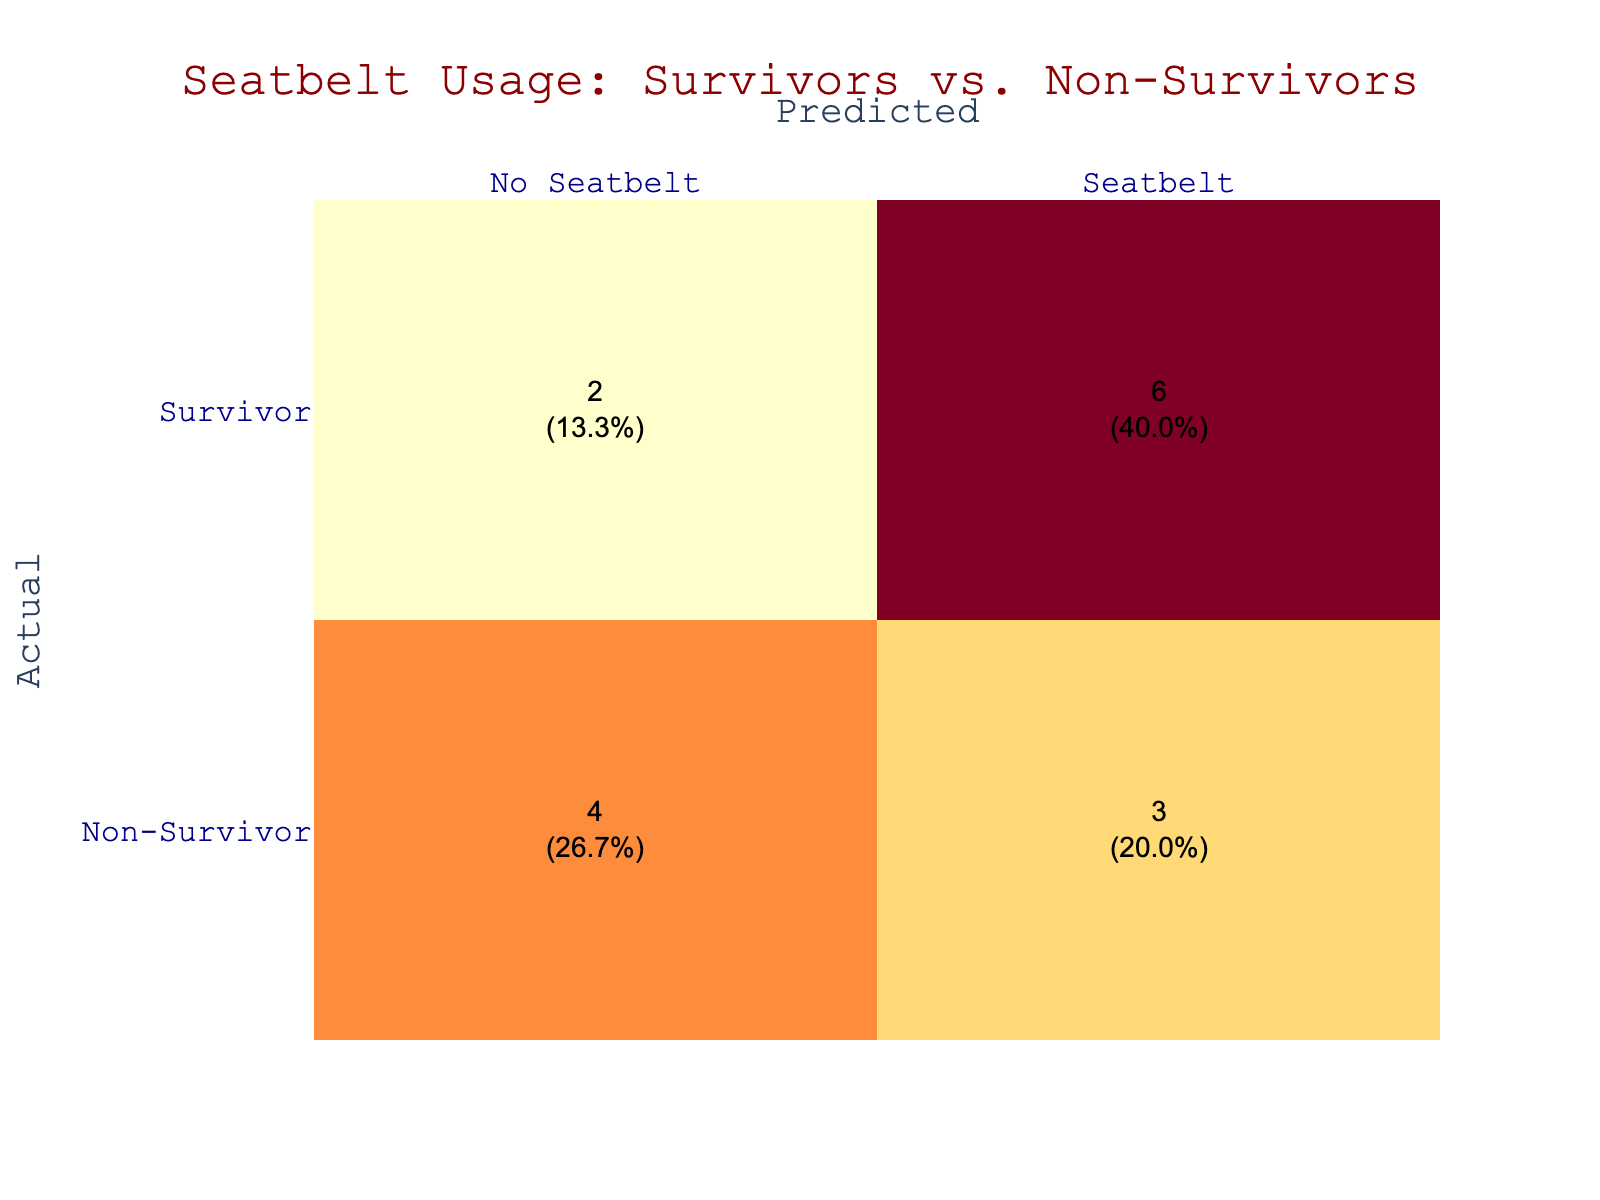What is the total number of survivors who used seatbelts? Referring to the table, I can see that there are four instances where survivors are predicted to have used seatbelts (Seatbelt under the Survivor category).
Answer: 4 How many non-survivors were observed to not use seatbelts? By checking the row for non-survivors and looking at the 'No Seatbelt' column, I find that there are four instances where non-survivors did not use seatbelts.
Answer: 4 Is it true that more survivors used seatbelts than non-survivors? To answer this, I can compare the totals for seatbelt usage: survivors who used seatbelts (4) and non-survivors who used seatbelts (3). Since 4 is greater than 3, the statement is true.
Answer: Yes What percentage of the total accidents involved survivors using seatbelts? First, I need to find the total number of cases, which is 15 (adding all entries). Next, I see there are 4 survivors using seatbelts. To get the percentage: (4/15)*100 = 26.7%.
Answer: 26.7% What is the difference between the number of non-survivors who used seatbelts and survivors who did not? Counting the non-survivors who used seatbelts gives me 3, and the survivors who did not use seatbelts is also 3. The difference is calculated as 3 - 3 = 0.
Answer: 0 How many total instances involved predictions of survivors? Looking at the table, there are 8 instances where the actual outcome is labeled as Survivor.
Answer: 8 What is the ratio of non-survivors using seatbelts to total non-survivors? From the table, I know there are 3 non-survivors using seatbelts and a total of 7 non-survivors (3 who used seatbelts and 4 who did not). The ratio is 3:7.
Answer: 3:7 Are there more survivors without seatbelts than non-survivors without seatbelts? I can see that there are 2 survivors without seatbelts and 4 non-survivors without seatbelts. Since 2 is less than 4, the statement is false.
Answer: No How many survivors were predicted to not use seatbelts, and what proportion does this represent of all survivors? The number of survivors who did not use seatbelts is 2, and the total number of survivors is 8. The proportion is calculated as (2/8)*100 = 25%.
Answer: 25% 